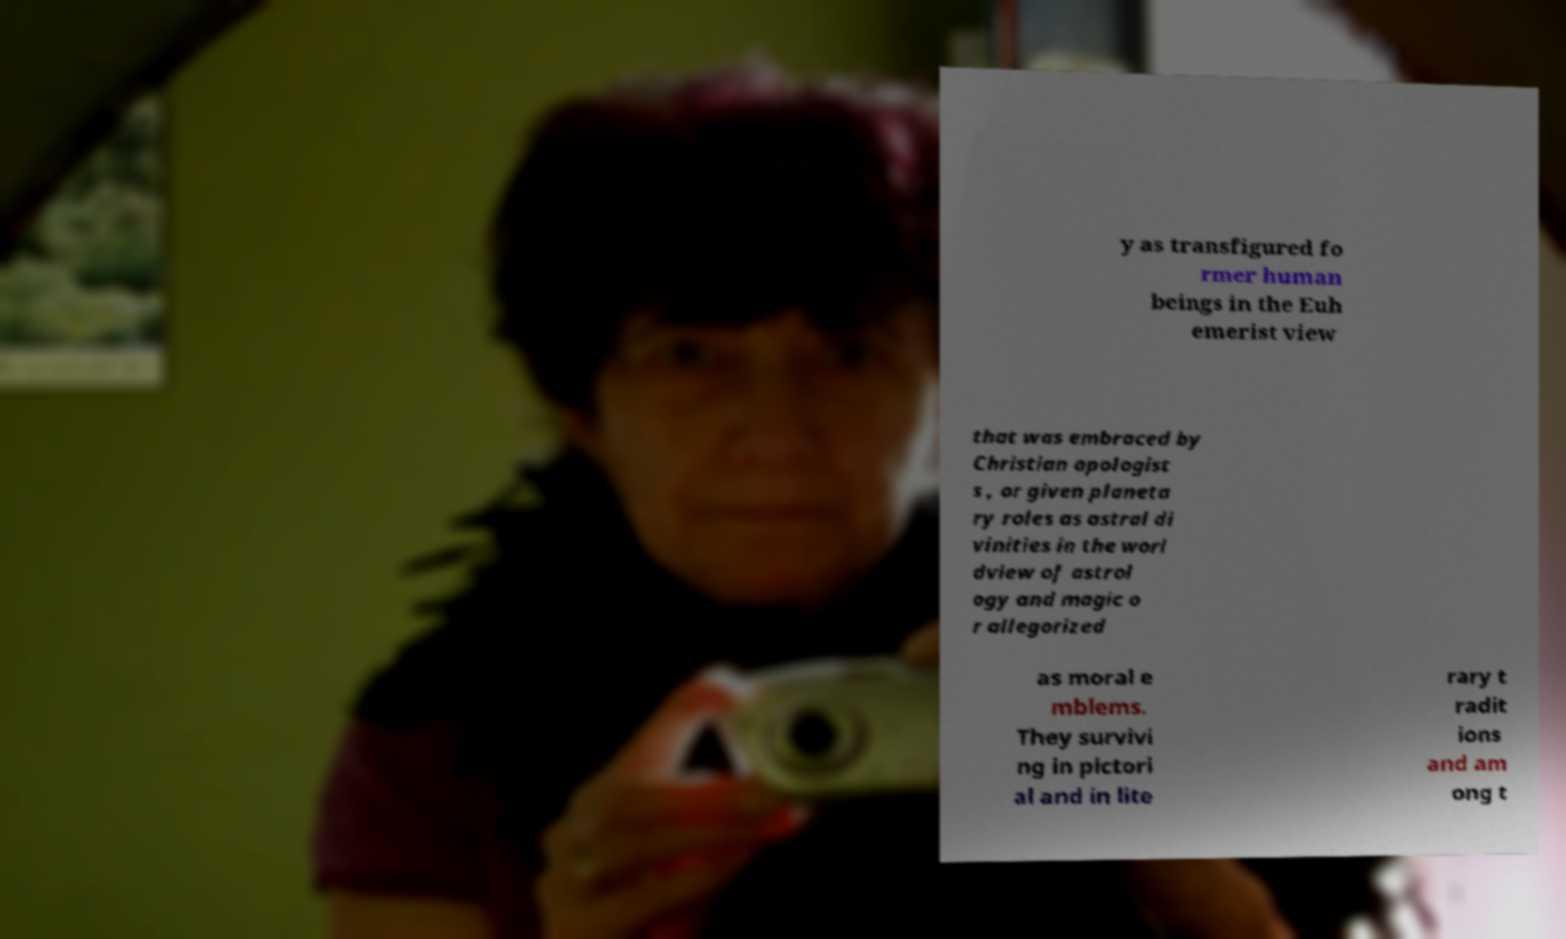Could you extract and type out the text from this image? y as transfigured fo rmer human beings in the Euh emerist view that was embraced by Christian apologist s , or given planeta ry roles as astral di vinities in the worl dview of astrol ogy and magic o r allegorized as moral e mblems. They survivi ng in pictori al and in lite rary t radit ions and am ong t 